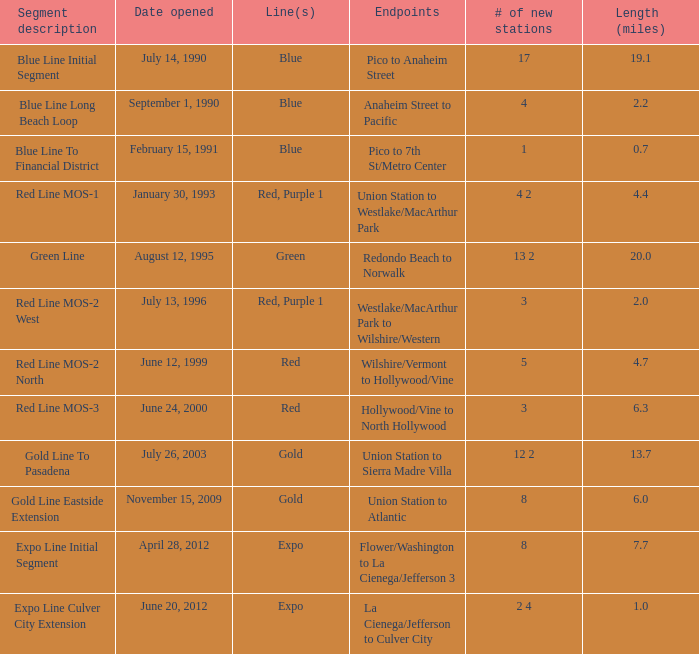What is the count of new stations that are 6.0 miles in length? 1.0. 